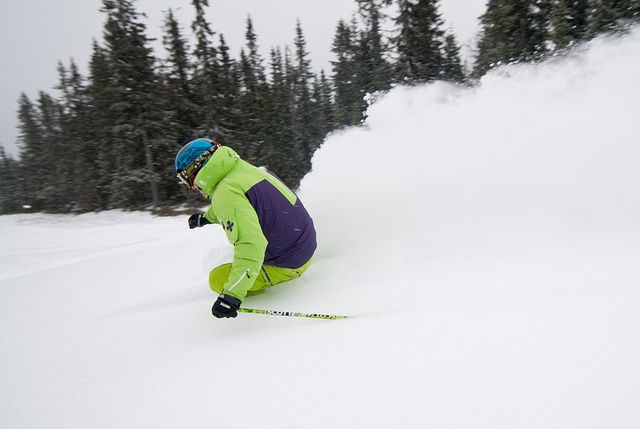Describe the objects in this image and their specific colors. I can see people in lightgray, lightgreen, navy, and black tones in this image. 